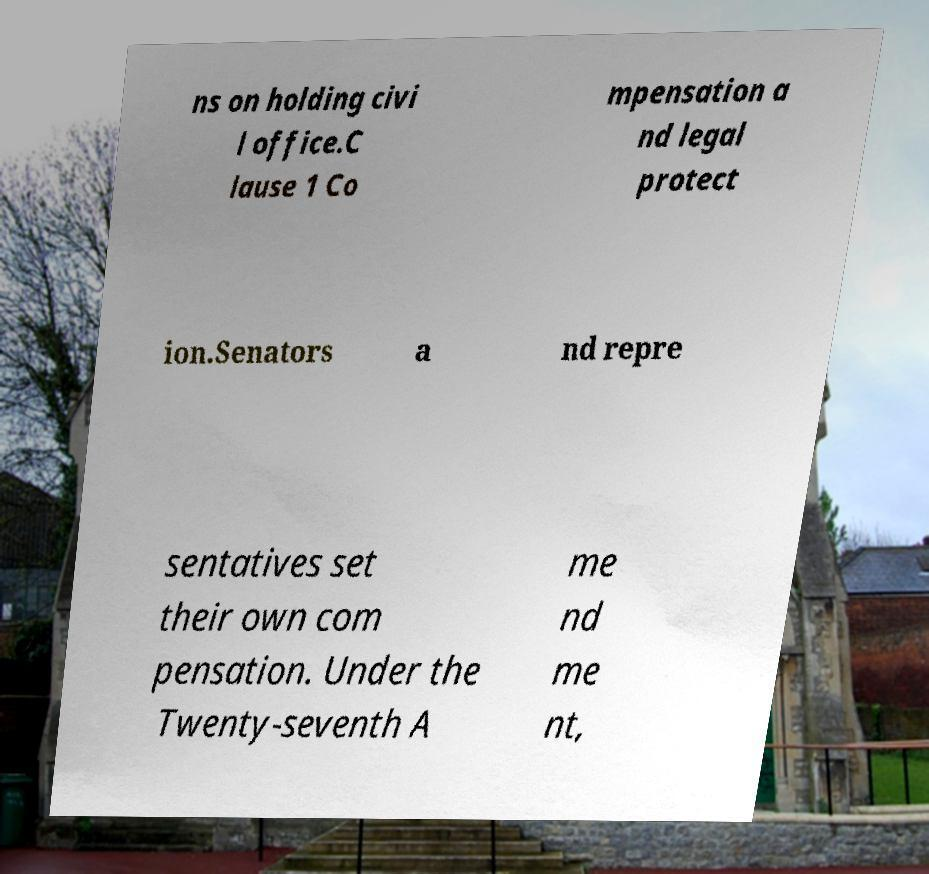Please read and relay the text visible in this image. What does it say? ns on holding civi l office.C lause 1 Co mpensation a nd legal protect ion.Senators a nd repre sentatives set their own com pensation. Under the Twenty-seventh A me nd me nt, 